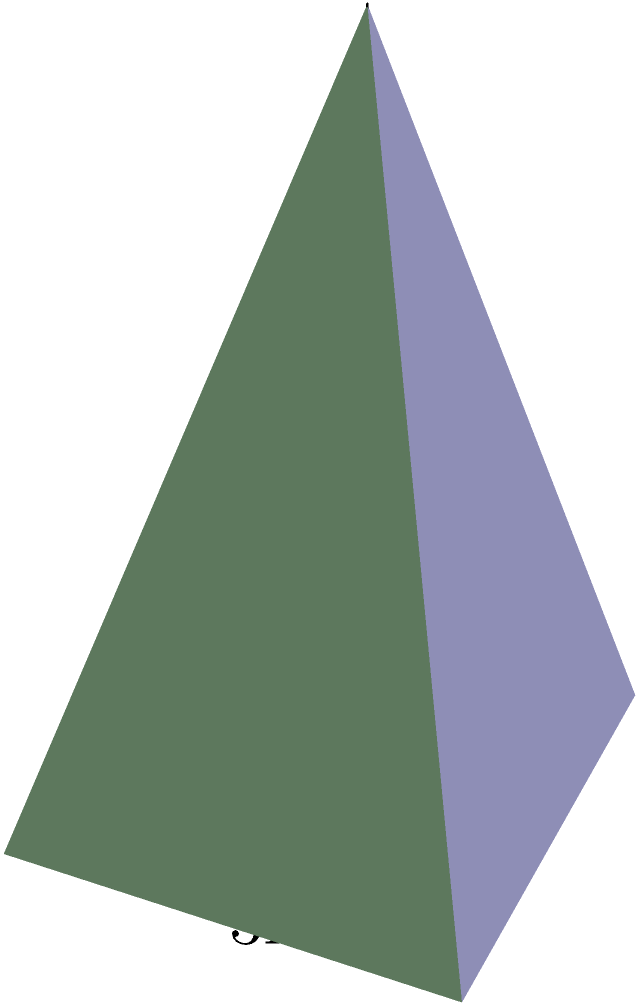As an expert in religious symbolism and ritual practices, you are tasked with designing a pyramid-shaped altar for a sacred ceremony. The base of the altar is rectangular with dimensions of 4 meters by 3 meters, and the height of the pyramid is 5 meters. Calculate the volume of this pyramid-shaped altar to ensure it meets the ceremonial requirements. To calculate the volume of a pyramid, we use the formula:

$$ V = \frac{1}{3} \times B \times h $$

Where:
$V$ = Volume
$B$ = Area of the base
$h$ = Height of the pyramid

Step 1: Calculate the area of the base (B)
The base is a rectangle with dimensions 4m × 3m
$$ B = 4m \times 3m = 12m^2 $$

Step 2: Identify the height (h)
The height is given as 5m

Step 3: Apply the volume formula
$$ V = \frac{1}{3} \times B \times h $$
$$ V = \frac{1}{3} \times 12m^2 \times 5m $$
$$ V = 20m^3 $$

Therefore, the volume of the pyramid-shaped altar is 20 cubic meters.
Answer: $20m^3$ 